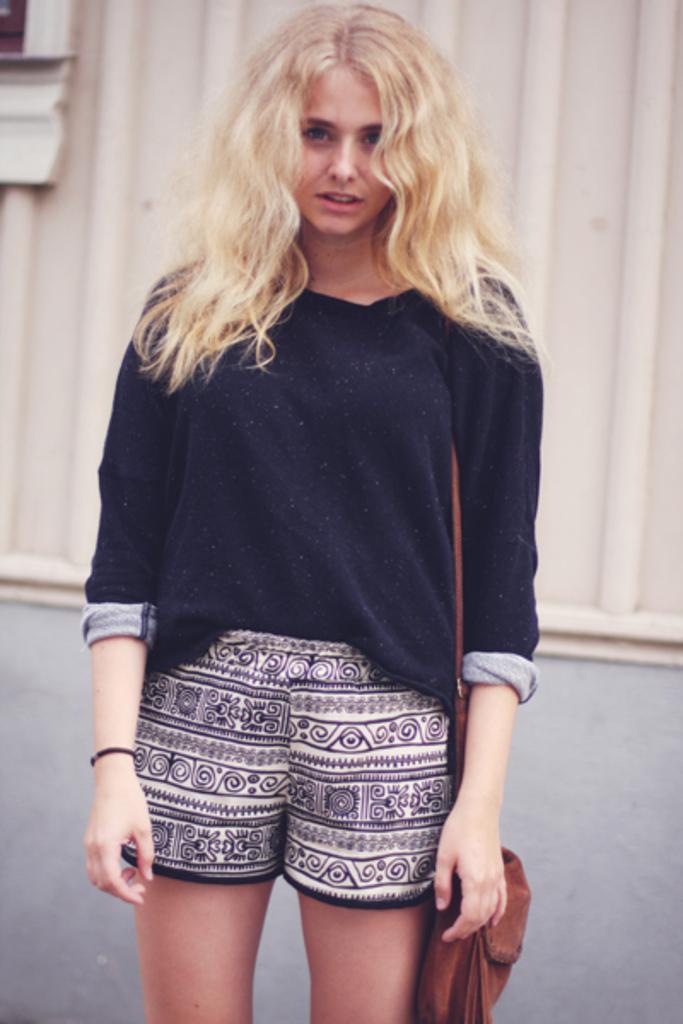Please provide a concise description of this image. In this image we can see a woman standing and carrying a bag, in the background we can see a wall. 